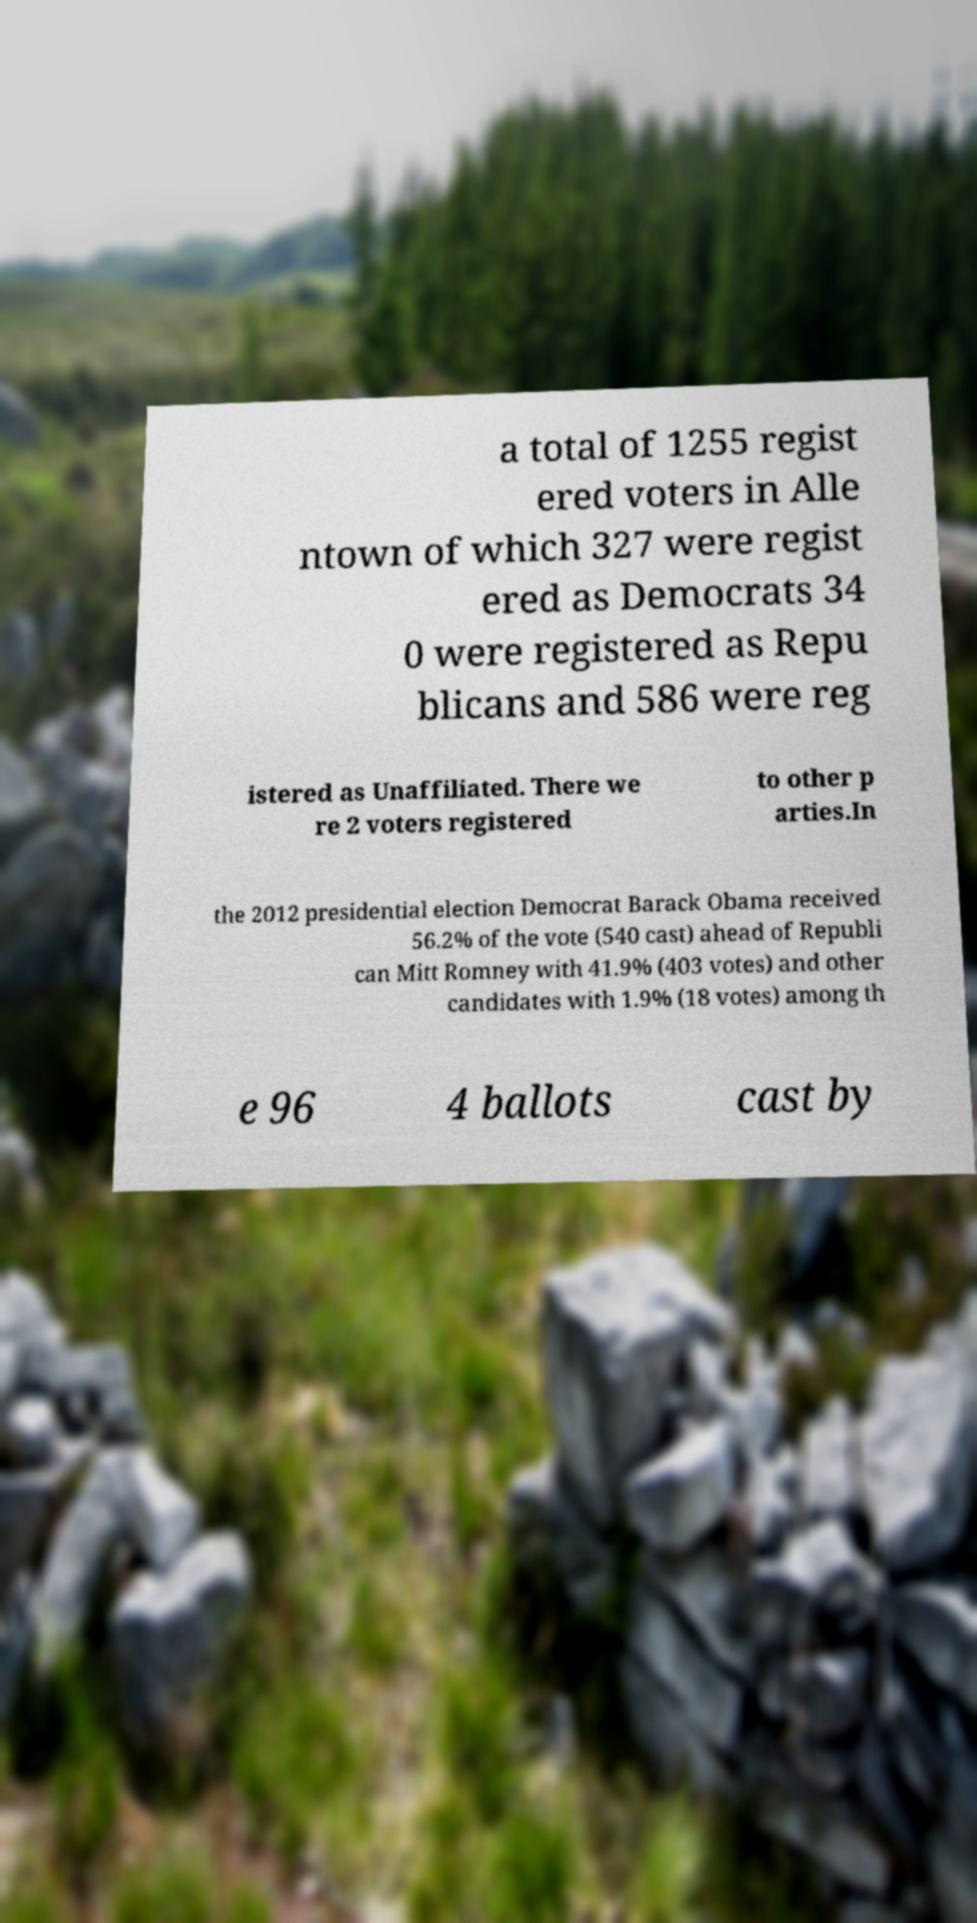Please read and relay the text visible in this image. What does it say? a total of 1255 regist ered voters in Alle ntown of which 327 were regist ered as Democrats 34 0 were registered as Repu blicans and 586 were reg istered as Unaffiliated. There we re 2 voters registered to other p arties.In the 2012 presidential election Democrat Barack Obama received 56.2% of the vote (540 cast) ahead of Republi can Mitt Romney with 41.9% (403 votes) and other candidates with 1.9% (18 votes) among th e 96 4 ballots cast by 